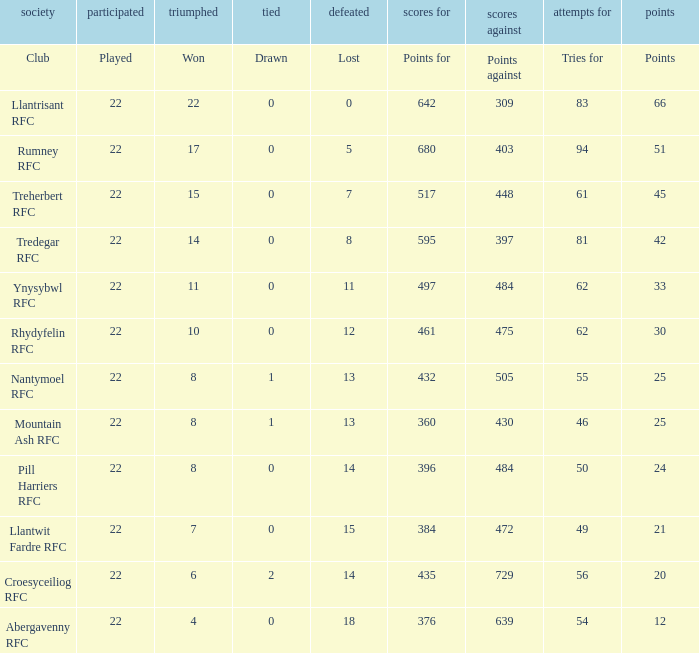How many tries were scored by the team with exactly 396 points? 50.0. 